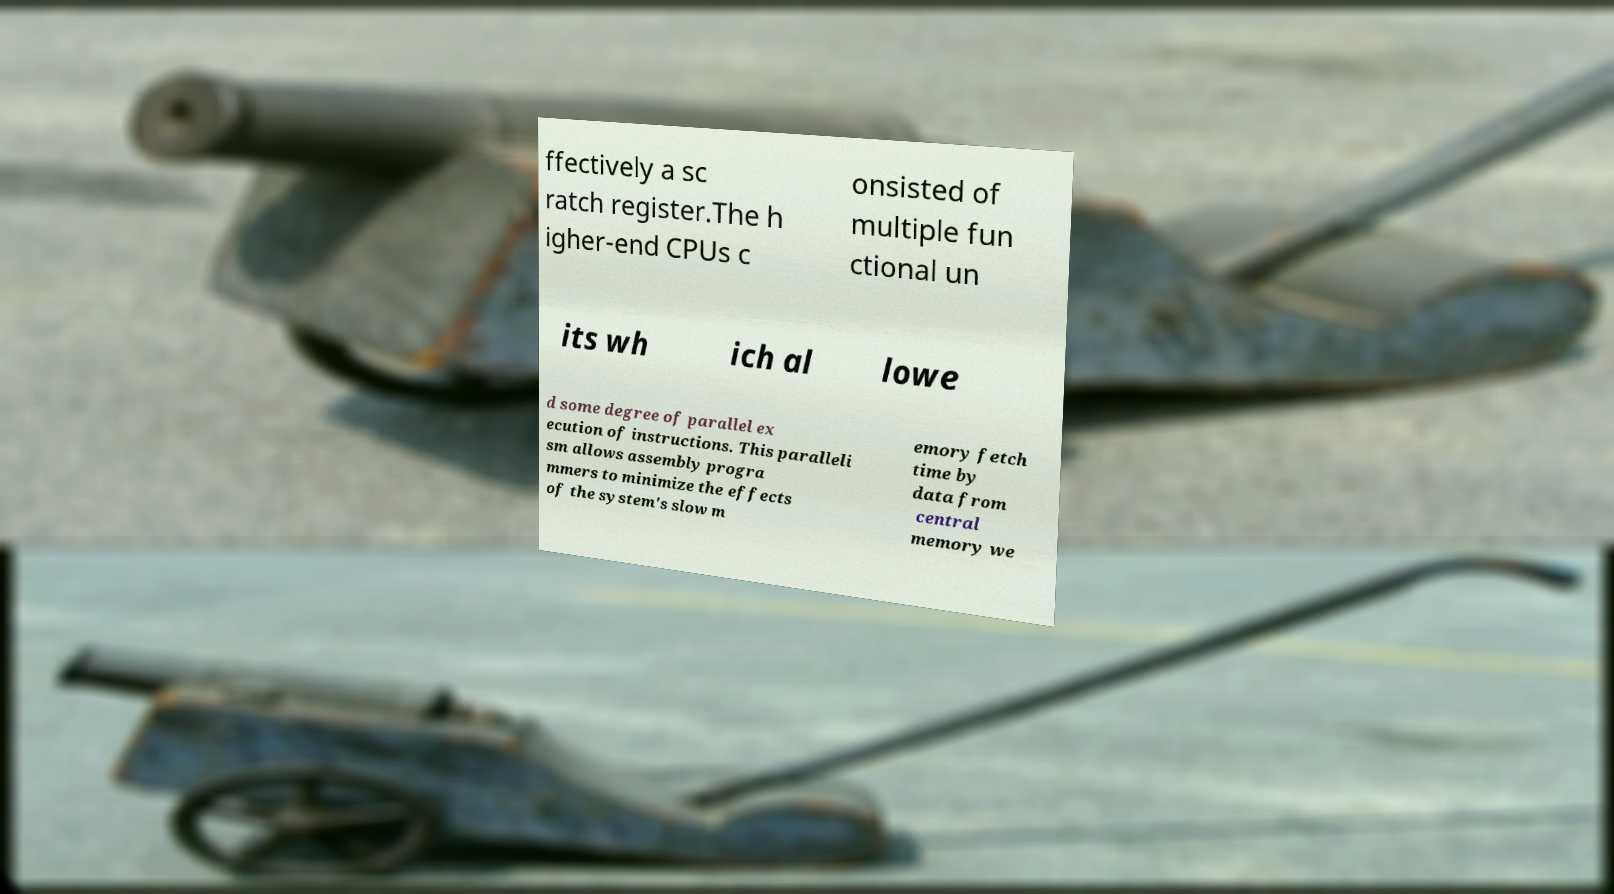Could you assist in decoding the text presented in this image and type it out clearly? ffectively a sc ratch register.The h igher-end CPUs c onsisted of multiple fun ctional un its wh ich al lowe d some degree of parallel ex ecution of instructions. This paralleli sm allows assembly progra mmers to minimize the effects of the system's slow m emory fetch time by data from central memory we 